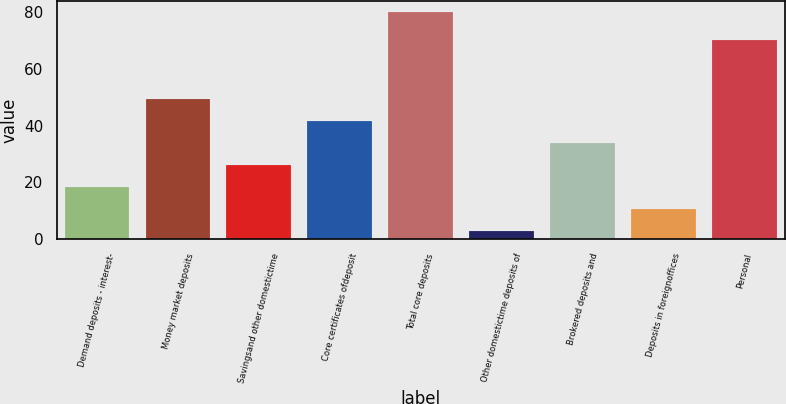Convert chart to OTSL. <chart><loc_0><loc_0><loc_500><loc_500><bar_chart><fcel>Demand deposits - interest-<fcel>Money market deposits<fcel>Savingsand other domestictime<fcel>Core certificates ofdeposit<fcel>Total core deposits<fcel>Other domestictime deposits of<fcel>Brokered deposits and<fcel>Deposits in foreignoffices<fcel>Personal<nl><fcel>18.4<fcel>49.2<fcel>26.1<fcel>41.5<fcel>80<fcel>3<fcel>33.8<fcel>10.7<fcel>70<nl></chart> 